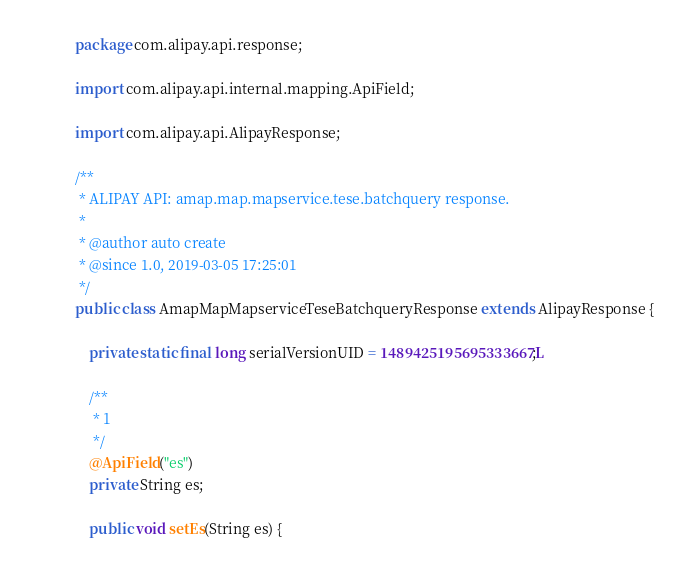Convert code to text. <code><loc_0><loc_0><loc_500><loc_500><_Java_>package com.alipay.api.response;

import com.alipay.api.internal.mapping.ApiField;

import com.alipay.api.AlipayResponse;

/**
 * ALIPAY API: amap.map.mapservice.tese.batchquery response.
 * 
 * @author auto create
 * @since 1.0, 2019-03-05 17:25:01
 */
public class AmapMapMapserviceTeseBatchqueryResponse extends AlipayResponse {

	private static final long serialVersionUID = 1489425195695333667L;

	/** 
	 * 1
	 */
	@ApiField("es")
	private String es;

	public void setEs(String es) {</code> 